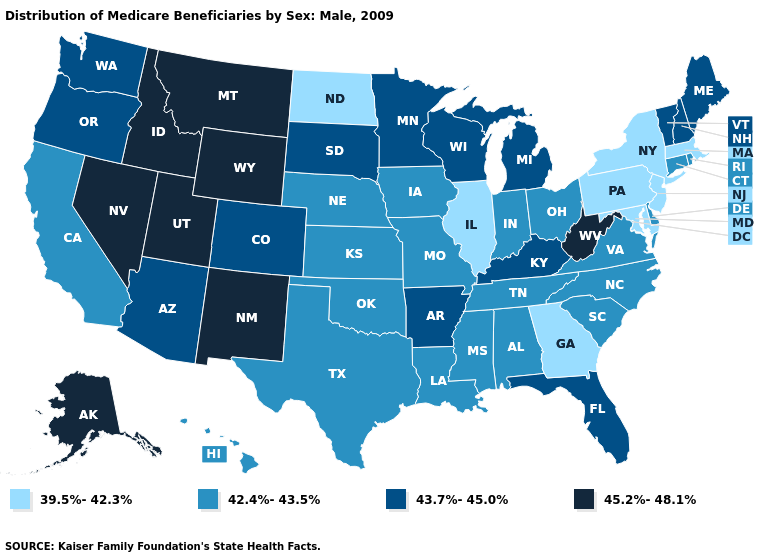Does Maine have the highest value in the Northeast?
Keep it brief. Yes. Among the states that border Wisconsin , which have the lowest value?
Short answer required. Illinois. What is the highest value in the USA?
Quick response, please. 45.2%-48.1%. What is the value of Alaska?
Concise answer only. 45.2%-48.1%. Which states have the highest value in the USA?
Answer briefly. Alaska, Idaho, Montana, Nevada, New Mexico, Utah, West Virginia, Wyoming. Which states have the lowest value in the USA?
Answer briefly. Georgia, Illinois, Maryland, Massachusetts, New Jersey, New York, North Dakota, Pennsylvania. Among the states that border West Virginia , which have the lowest value?
Write a very short answer. Maryland, Pennsylvania. Which states have the lowest value in the MidWest?
Short answer required. Illinois, North Dakota. Name the states that have a value in the range 39.5%-42.3%?
Short answer required. Georgia, Illinois, Maryland, Massachusetts, New Jersey, New York, North Dakota, Pennsylvania. Does Nevada have the highest value in the USA?
Write a very short answer. Yes. What is the value of Hawaii?
Be succinct. 42.4%-43.5%. What is the value of Vermont?
Short answer required. 43.7%-45.0%. What is the value of Montana?
Concise answer only. 45.2%-48.1%. Among the states that border Iowa , which have the lowest value?
Answer briefly. Illinois. What is the value of Arizona?
Short answer required. 43.7%-45.0%. 